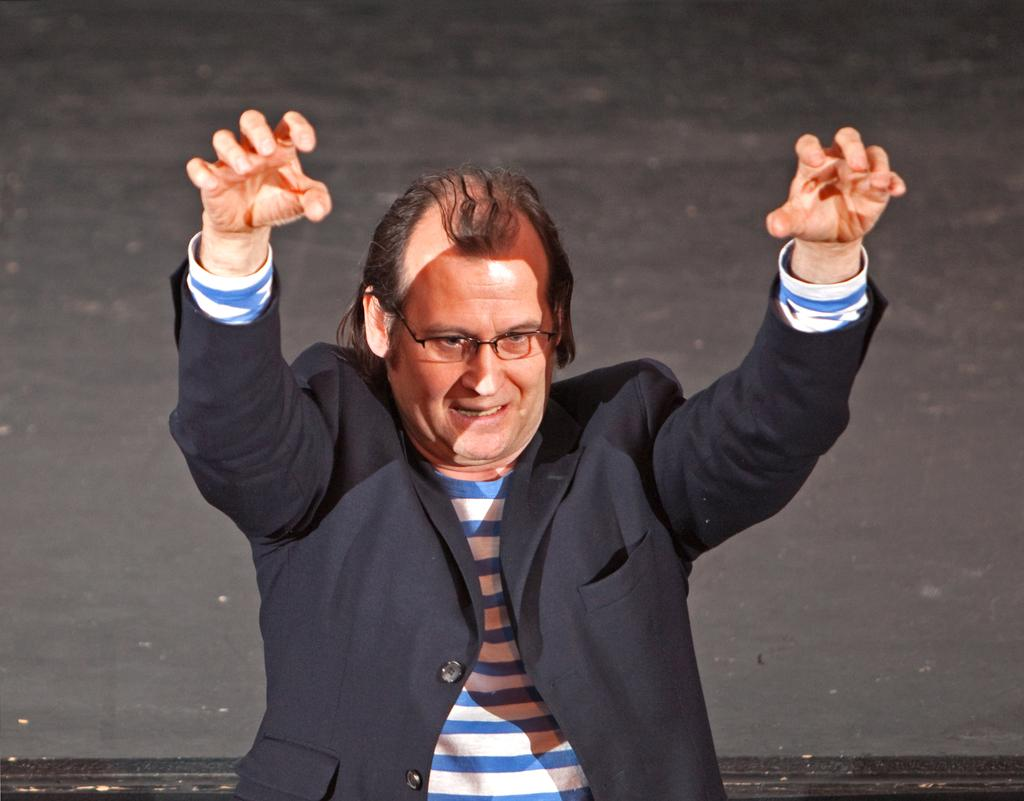What is the main subject of the image? There is a person in the image. What is the person wearing? The person is wearing a black suit. What is the person doing in the image? The person is standing and talking. What is the color of the background in the image? The background in the image is black. What type of frog can be seen climbing the mountain in the image? There is no frog or mountain present in the image; it features a person wearing a black suit against a black background. 